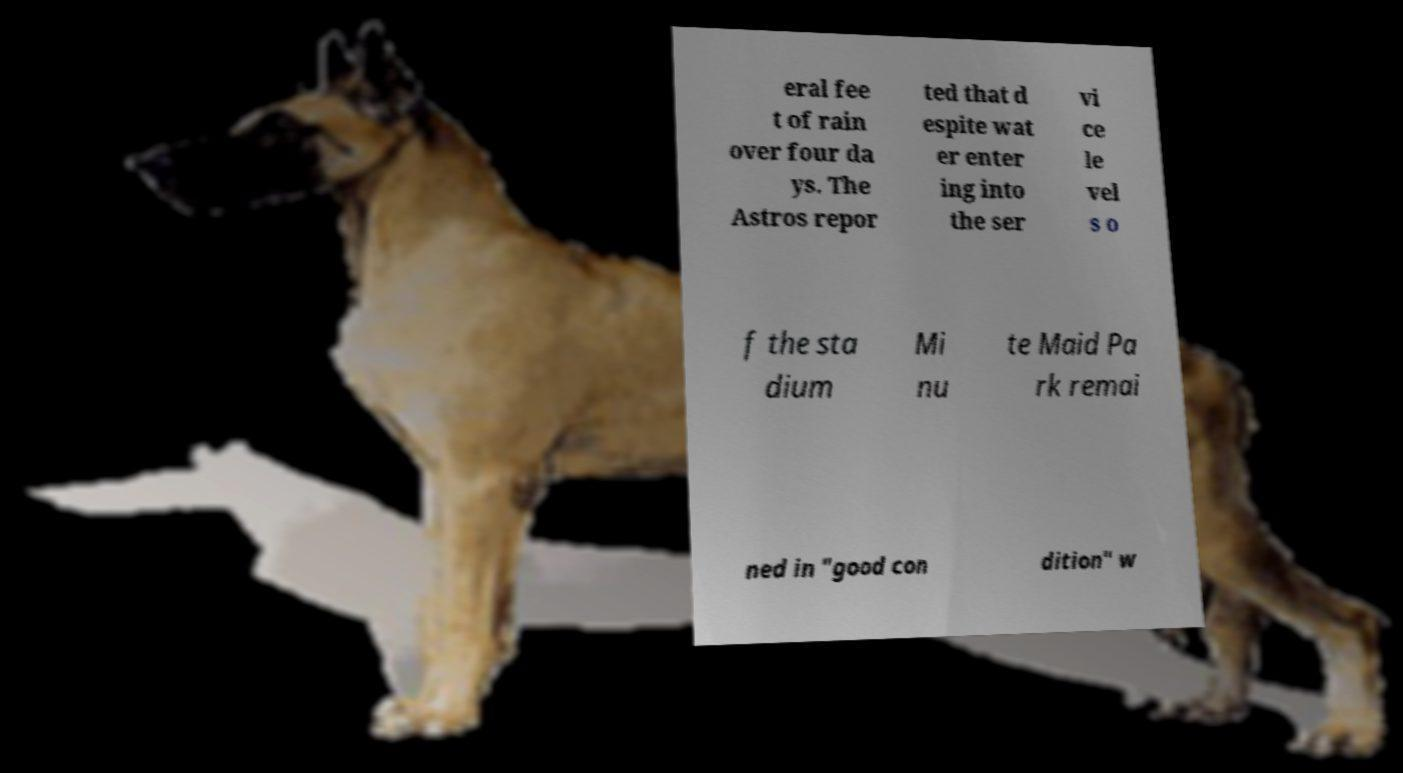Please read and relay the text visible in this image. What does it say? eral fee t of rain over four da ys. The Astros repor ted that d espite wat er enter ing into the ser vi ce le vel s o f the sta dium Mi nu te Maid Pa rk remai ned in "good con dition" w 